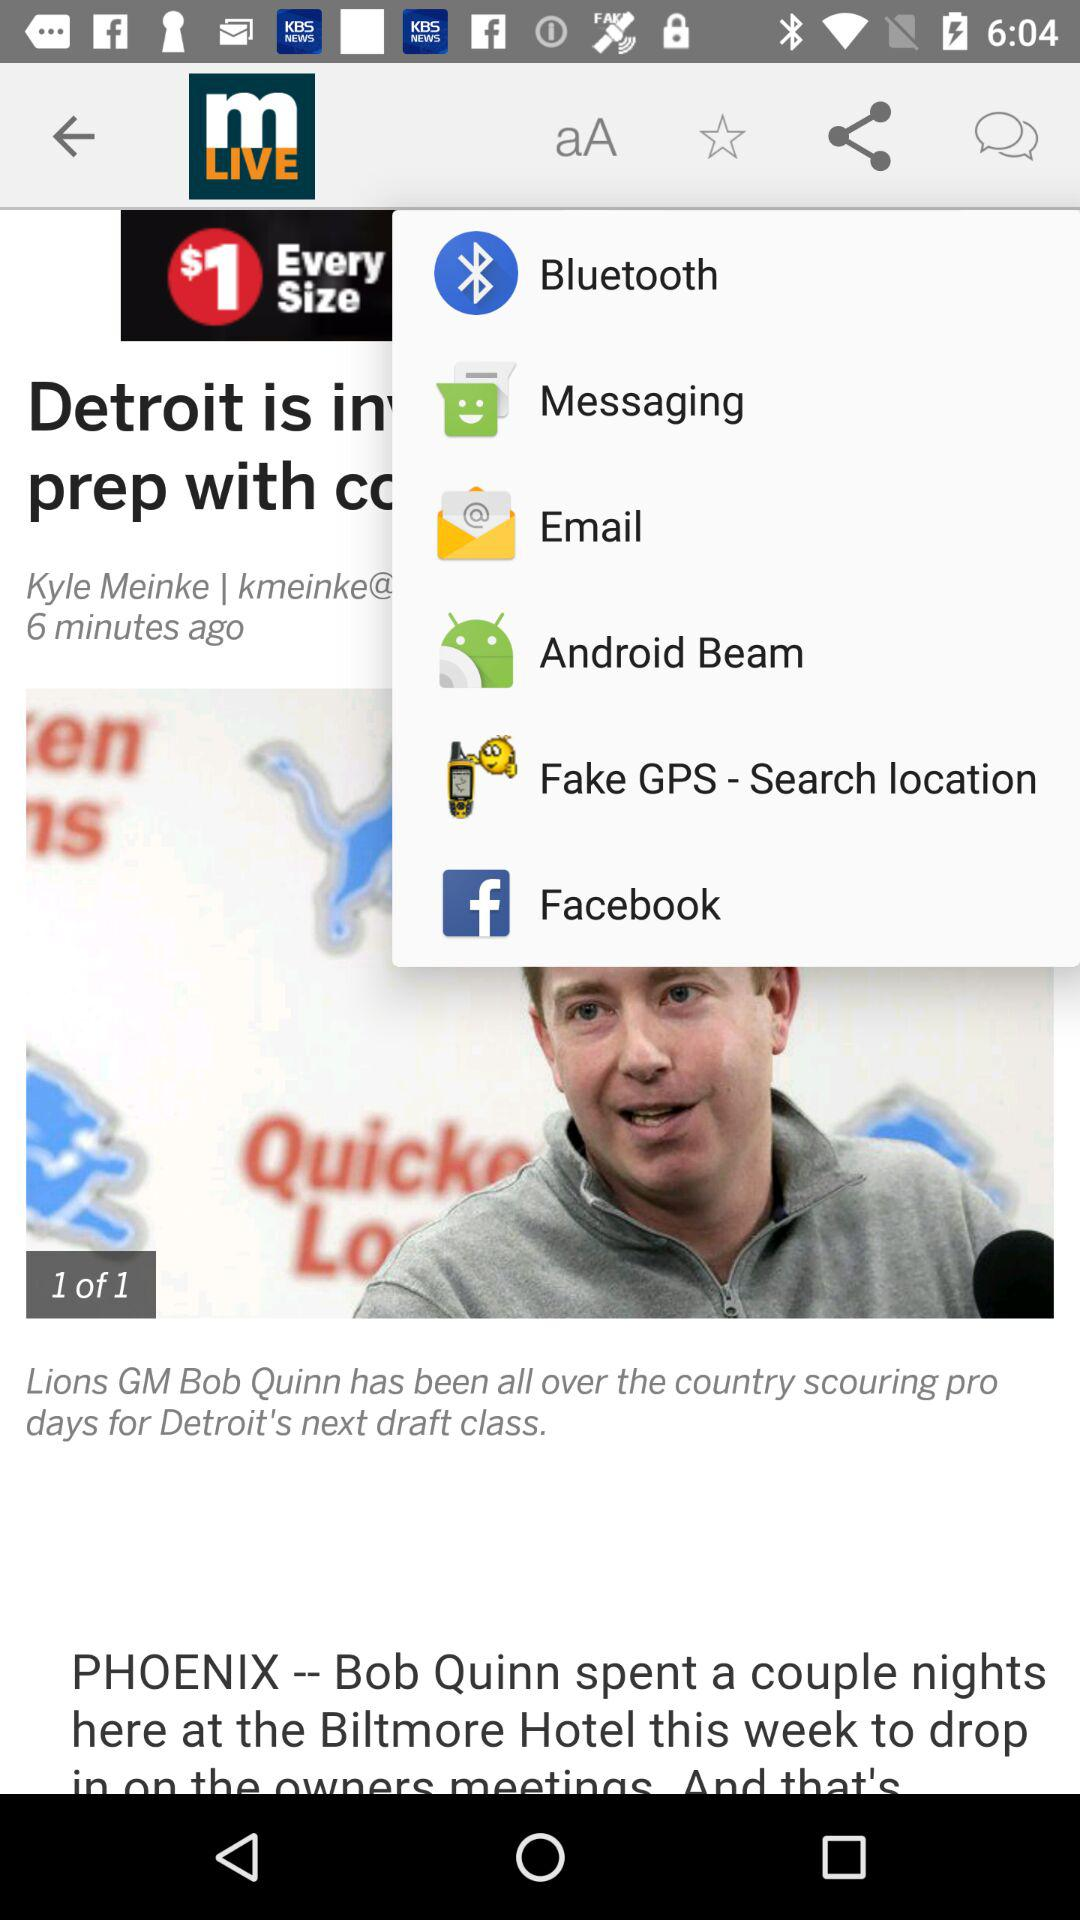What is the media caption given on the screen? The media caption given on the screen is "Lions GM Bob Quinn has been all over the country scouring pro days for Detroit's next draft class". 